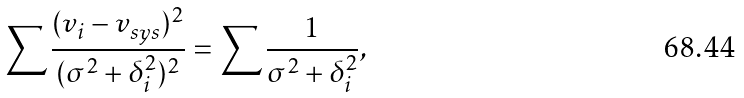Convert formula to latex. <formula><loc_0><loc_0><loc_500><loc_500>\sum \frac { ( v _ { i } - v _ { s y s } ) ^ { 2 } } { ( \sigma ^ { 2 } + \delta _ { i } ^ { 2 } ) ^ { 2 } } = \sum \frac { 1 } { \sigma ^ { 2 } + \delta _ { i } ^ { 2 } } ,</formula> 